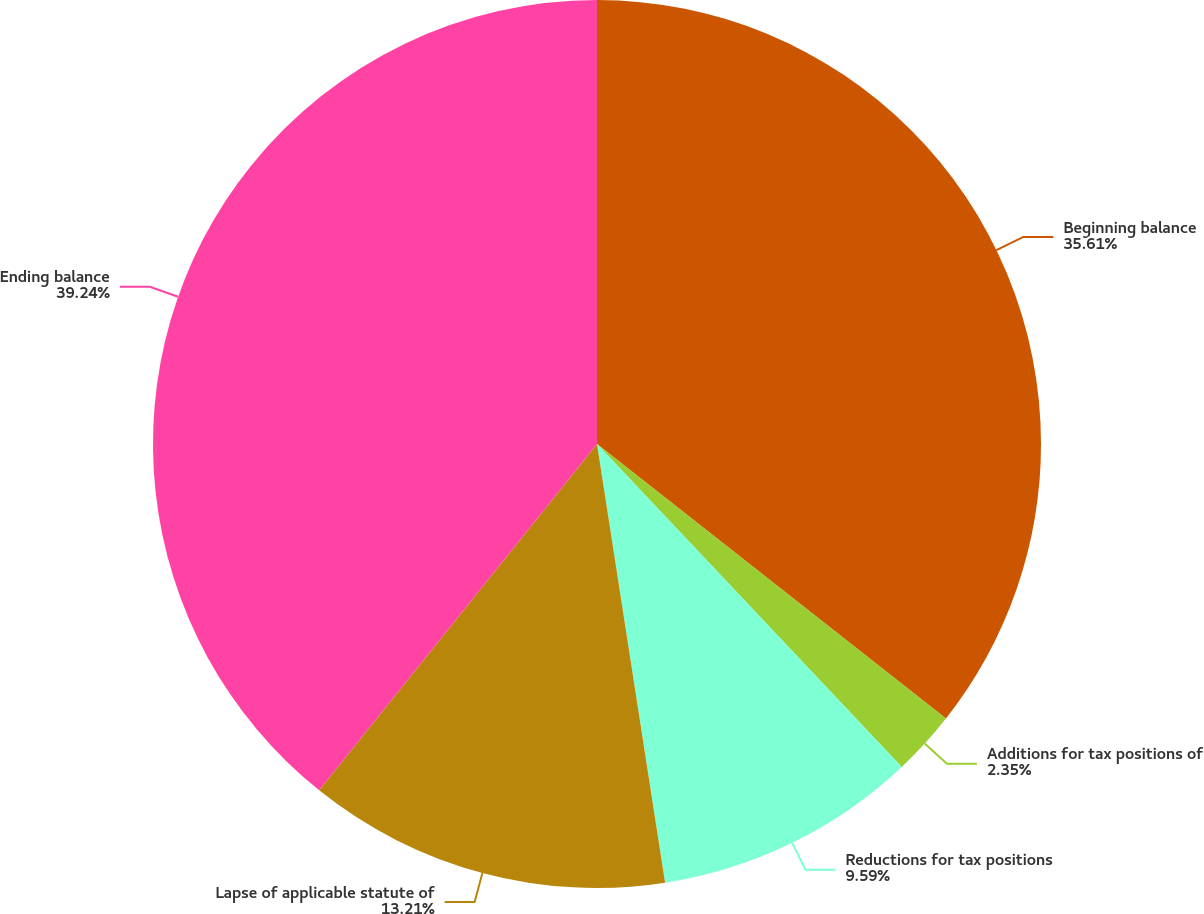<chart> <loc_0><loc_0><loc_500><loc_500><pie_chart><fcel>Beginning balance<fcel>Additions for tax positions of<fcel>Reductions for tax positions<fcel>Lapse of applicable statute of<fcel>Ending balance<nl><fcel>35.61%<fcel>2.35%<fcel>9.59%<fcel>13.21%<fcel>39.24%<nl></chart> 